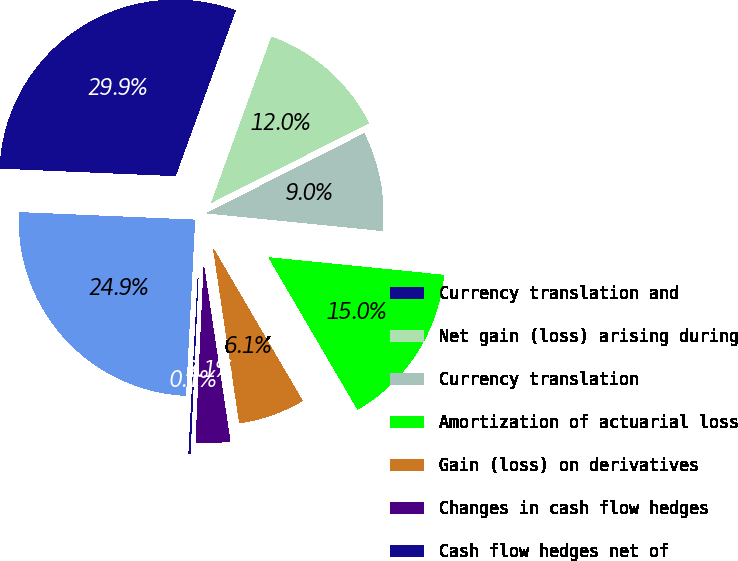Convert chart to OTSL. <chart><loc_0><loc_0><loc_500><loc_500><pie_chart><fcel>Currency translation and<fcel>Net gain (loss) arising during<fcel>Currency translation<fcel>Amortization of actuarial loss<fcel>Gain (loss) on derivatives<fcel>Changes in cash flow hedges<fcel>Cash flow hedges net of<fcel>Other comprehensive income<nl><fcel>29.86%<fcel>12.01%<fcel>9.04%<fcel>14.98%<fcel>6.06%<fcel>3.09%<fcel>0.11%<fcel>24.85%<nl></chart> 